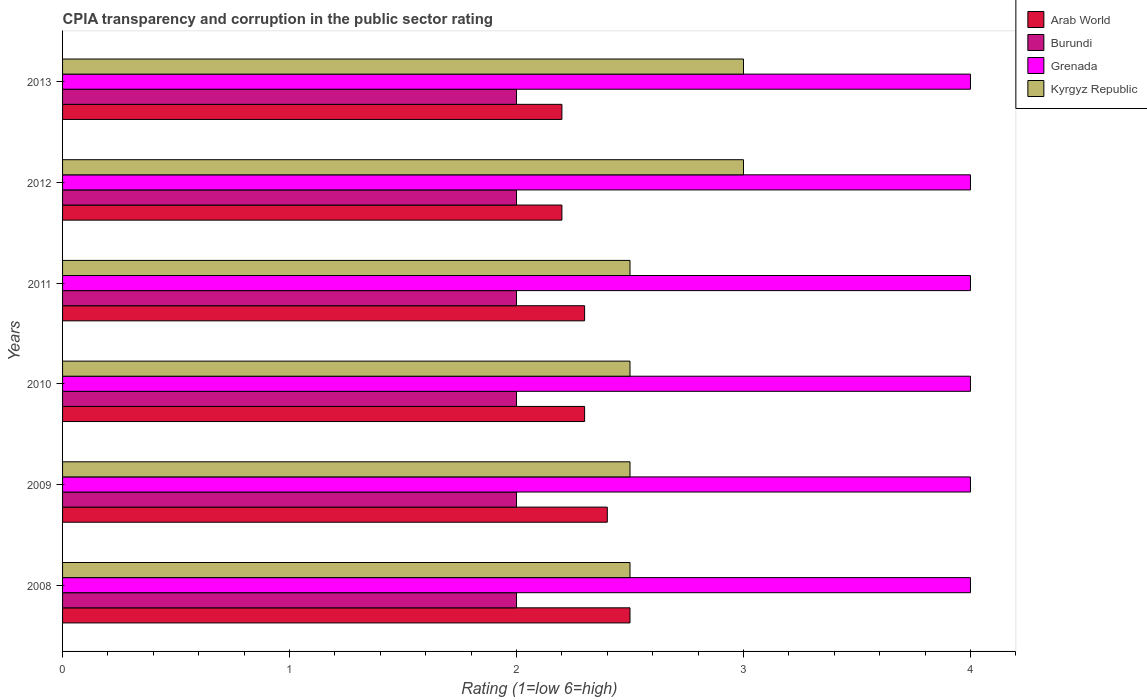In how many cases, is the number of bars for a given year not equal to the number of legend labels?
Your answer should be compact. 0. Across all years, what is the maximum CPIA rating in Grenada?
Your answer should be compact. 4. Across all years, what is the minimum CPIA rating in Grenada?
Your response must be concise. 4. In which year was the CPIA rating in Arab World maximum?
Ensure brevity in your answer.  2008. What is the total CPIA rating in Grenada in the graph?
Offer a terse response. 24. What is the difference between the CPIA rating in Kyrgyz Republic in 2009 and that in 2013?
Give a very brief answer. -0.5. What is the difference between the CPIA rating in Grenada in 2010 and the CPIA rating in Kyrgyz Republic in 2011?
Your answer should be very brief. 1.5. In the year 2013, what is the difference between the CPIA rating in Arab World and CPIA rating in Grenada?
Offer a terse response. -1.8. What is the ratio of the CPIA rating in Kyrgyz Republic in 2009 to that in 2012?
Ensure brevity in your answer.  0.83. Is the CPIA rating in Burundi in 2011 less than that in 2012?
Keep it short and to the point. No. Is the difference between the CPIA rating in Arab World in 2009 and 2013 greater than the difference between the CPIA rating in Grenada in 2009 and 2013?
Your answer should be compact. Yes. In how many years, is the CPIA rating in Kyrgyz Republic greater than the average CPIA rating in Kyrgyz Republic taken over all years?
Keep it short and to the point. 2. Is the sum of the CPIA rating in Burundi in 2012 and 2013 greater than the maximum CPIA rating in Arab World across all years?
Offer a terse response. Yes. What does the 1st bar from the top in 2009 represents?
Provide a succinct answer. Kyrgyz Republic. What does the 3rd bar from the bottom in 2012 represents?
Your response must be concise. Grenada. Are all the bars in the graph horizontal?
Provide a succinct answer. Yes. Where does the legend appear in the graph?
Your response must be concise. Top right. How many legend labels are there?
Give a very brief answer. 4. How are the legend labels stacked?
Keep it short and to the point. Vertical. What is the title of the graph?
Make the answer very short. CPIA transparency and corruption in the public sector rating. Does "Channel Islands" appear as one of the legend labels in the graph?
Make the answer very short. No. What is the Rating (1=low 6=high) in Grenada in 2008?
Keep it short and to the point. 4. What is the Rating (1=low 6=high) of Kyrgyz Republic in 2008?
Give a very brief answer. 2.5. What is the Rating (1=low 6=high) in Arab World in 2009?
Make the answer very short. 2.4. What is the Rating (1=low 6=high) of Kyrgyz Republic in 2009?
Offer a very short reply. 2.5. What is the Rating (1=low 6=high) in Arab World in 2010?
Provide a succinct answer. 2.3. What is the Rating (1=low 6=high) in Kyrgyz Republic in 2010?
Keep it short and to the point. 2.5. What is the Rating (1=low 6=high) in Burundi in 2011?
Provide a succinct answer. 2. What is the Rating (1=low 6=high) of Arab World in 2012?
Give a very brief answer. 2.2. What is the Rating (1=low 6=high) of Burundi in 2012?
Ensure brevity in your answer.  2. What is the Rating (1=low 6=high) in Grenada in 2012?
Your response must be concise. 4. What is the Rating (1=low 6=high) of Grenada in 2013?
Your response must be concise. 4. What is the Rating (1=low 6=high) of Kyrgyz Republic in 2013?
Your answer should be compact. 3. Across all years, what is the maximum Rating (1=low 6=high) of Arab World?
Give a very brief answer. 2.5. Across all years, what is the maximum Rating (1=low 6=high) of Burundi?
Make the answer very short. 2. Across all years, what is the maximum Rating (1=low 6=high) in Grenada?
Your response must be concise. 4. Across all years, what is the maximum Rating (1=low 6=high) of Kyrgyz Republic?
Give a very brief answer. 3. Across all years, what is the minimum Rating (1=low 6=high) of Arab World?
Make the answer very short. 2.2. Across all years, what is the minimum Rating (1=low 6=high) of Burundi?
Keep it short and to the point. 2. Across all years, what is the minimum Rating (1=low 6=high) in Kyrgyz Republic?
Your answer should be very brief. 2.5. What is the total Rating (1=low 6=high) in Burundi in the graph?
Make the answer very short. 12. What is the total Rating (1=low 6=high) in Grenada in the graph?
Provide a short and direct response. 24. What is the total Rating (1=low 6=high) of Kyrgyz Republic in the graph?
Keep it short and to the point. 16. What is the difference between the Rating (1=low 6=high) of Kyrgyz Republic in 2008 and that in 2009?
Ensure brevity in your answer.  0. What is the difference between the Rating (1=low 6=high) in Arab World in 2008 and that in 2011?
Provide a succinct answer. 0.2. What is the difference between the Rating (1=low 6=high) of Kyrgyz Republic in 2008 and that in 2012?
Keep it short and to the point. -0.5. What is the difference between the Rating (1=low 6=high) in Arab World in 2008 and that in 2013?
Offer a terse response. 0.3. What is the difference between the Rating (1=low 6=high) of Grenada in 2008 and that in 2013?
Keep it short and to the point. 0. What is the difference between the Rating (1=low 6=high) of Kyrgyz Republic in 2008 and that in 2013?
Provide a succinct answer. -0.5. What is the difference between the Rating (1=low 6=high) in Burundi in 2009 and that in 2010?
Offer a terse response. 0. What is the difference between the Rating (1=low 6=high) of Kyrgyz Republic in 2009 and that in 2010?
Make the answer very short. 0. What is the difference between the Rating (1=low 6=high) in Kyrgyz Republic in 2009 and that in 2011?
Offer a terse response. 0. What is the difference between the Rating (1=low 6=high) in Arab World in 2009 and that in 2012?
Provide a succinct answer. 0.2. What is the difference between the Rating (1=low 6=high) in Kyrgyz Republic in 2009 and that in 2012?
Keep it short and to the point. -0.5. What is the difference between the Rating (1=low 6=high) of Grenada in 2009 and that in 2013?
Make the answer very short. 0. What is the difference between the Rating (1=low 6=high) in Burundi in 2010 and that in 2011?
Offer a terse response. 0. What is the difference between the Rating (1=low 6=high) of Arab World in 2010 and that in 2012?
Provide a succinct answer. 0.1. What is the difference between the Rating (1=low 6=high) of Kyrgyz Republic in 2010 and that in 2012?
Your answer should be very brief. -0.5. What is the difference between the Rating (1=low 6=high) of Burundi in 2010 and that in 2013?
Your answer should be very brief. 0. What is the difference between the Rating (1=low 6=high) in Grenada in 2010 and that in 2013?
Your answer should be compact. 0. What is the difference between the Rating (1=low 6=high) in Kyrgyz Republic in 2010 and that in 2013?
Offer a very short reply. -0.5. What is the difference between the Rating (1=low 6=high) in Arab World in 2011 and that in 2012?
Your answer should be very brief. 0.1. What is the difference between the Rating (1=low 6=high) of Kyrgyz Republic in 2011 and that in 2012?
Offer a very short reply. -0.5. What is the difference between the Rating (1=low 6=high) of Arab World in 2011 and that in 2013?
Make the answer very short. 0.1. What is the difference between the Rating (1=low 6=high) of Grenada in 2011 and that in 2013?
Provide a short and direct response. 0. What is the difference between the Rating (1=low 6=high) in Burundi in 2012 and that in 2013?
Your answer should be very brief. 0. What is the difference between the Rating (1=low 6=high) of Kyrgyz Republic in 2012 and that in 2013?
Ensure brevity in your answer.  0. What is the difference between the Rating (1=low 6=high) in Arab World in 2008 and the Rating (1=low 6=high) in Kyrgyz Republic in 2009?
Your response must be concise. 0. What is the difference between the Rating (1=low 6=high) in Burundi in 2008 and the Rating (1=low 6=high) in Grenada in 2009?
Keep it short and to the point. -2. What is the difference between the Rating (1=low 6=high) in Burundi in 2008 and the Rating (1=low 6=high) in Kyrgyz Republic in 2009?
Keep it short and to the point. -0.5. What is the difference between the Rating (1=low 6=high) of Grenada in 2008 and the Rating (1=low 6=high) of Kyrgyz Republic in 2009?
Your answer should be compact. 1.5. What is the difference between the Rating (1=low 6=high) in Arab World in 2008 and the Rating (1=low 6=high) in Burundi in 2010?
Offer a very short reply. 0.5. What is the difference between the Rating (1=low 6=high) of Arab World in 2008 and the Rating (1=low 6=high) of Kyrgyz Republic in 2010?
Offer a terse response. 0. What is the difference between the Rating (1=low 6=high) in Burundi in 2008 and the Rating (1=low 6=high) in Grenada in 2011?
Provide a succinct answer. -2. What is the difference between the Rating (1=low 6=high) in Arab World in 2008 and the Rating (1=low 6=high) in Burundi in 2012?
Provide a succinct answer. 0.5. What is the difference between the Rating (1=low 6=high) of Burundi in 2008 and the Rating (1=low 6=high) of Grenada in 2012?
Give a very brief answer. -2. What is the difference between the Rating (1=low 6=high) of Burundi in 2008 and the Rating (1=low 6=high) of Kyrgyz Republic in 2012?
Provide a succinct answer. -1. What is the difference between the Rating (1=low 6=high) of Grenada in 2008 and the Rating (1=low 6=high) of Kyrgyz Republic in 2012?
Give a very brief answer. 1. What is the difference between the Rating (1=low 6=high) in Arab World in 2008 and the Rating (1=low 6=high) in Burundi in 2013?
Your response must be concise. 0.5. What is the difference between the Rating (1=low 6=high) in Arab World in 2008 and the Rating (1=low 6=high) in Grenada in 2013?
Provide a succinct answer. -1.5. What is the difference between the Rating (1=low 6=high) in Burundi in 2008 and the Rating (1=low 6=high) in Grenada in 2013?
Provide a succinct answer. -2. What is the difference between the Rating (1=low 6=high) of Burundi in 2008 and the Rating (1=low 6=high) of Kyrgyz Republic in 2013?
Give a very brief answer. -1. What is the difference between the Rating (1=low 6=high) in Grenada in 2008 and the Rating (1=low 6=high) in Kyrgyz Republic in 2013?
Provide a succinct answer. 1. What is the difference between the Rating (1=low 6=high) in Grenada in 2009 and the Rating (1=low 6=high) in Kyrgyz Republic in 2010?
Provide a short and direct response. 1.5. What is the difference between the Rating (1=low 6=high) in Arab World in 2009 and the Rating (1=low 6=high) in Burundi in 2011?
Make the answer very short. 0.4. What is the difference between the Rating (1=low 6=high) of Arab World in 2009 and the Rating (1=low 6=high) of Grenada in 2011?
Ensure brevity in your answer.  -1.6. What is the difference between the Rating (1=low 6=high) of Burundi in 2009 and the Rating (1=low 6=high) of Grenada in 2011?
Your answer should be compact. -2. What is the difference between the Rating (1=low 6=high) of Burundi in 2009 and the Rating (1=low 6=high) of Kyrgyz Republic in 2011?
Offer a terse response. -0.5. What is the difference between the Rating (1=low 6=high) of Arab World in 2009 and the Rating (1=low 6=high) of Burundi in 2012?
Ensure brevity in your answer.  0.4. What is the difference between the Rating (1=low 6=high) of Arab World in 2009 and the Rating (1=low 6=high) of Grenada in 2012?
Your answer should be compact. -1.6. What is the difference between the Rating (1=low 6=high) in Arab World in 2009 and the Rating (1=low 6=high) in Burundi in 2013?
Give a very brief answer. 0.4. What is the difference between the Rating (1=low 6=high) of Arab World in 2009 and the Rating (1=low 6=high) of Grenada in 2013?
Your answer should be very brief. -1.6. What is the difference between the Rating (1=low 6=high) of Arab World in 2009 and the Rating (1=low 6=high) of Kyrgyz Republic in 2013?
Your answer should be very brief. -0.6. What is the difference between the Rating (1=low 6=high) in Burundi in 2009 and the Rating (1=low 6=high) in Grenada in 2013?
Your answer should be very brief. -2. What is the difference between the Rating (1=low 6=high) in Arab World in 2010 and the Rating (1=low 6=high) in Burundi in 2011?
Give a very brief answer. 0.3. What is the difference between the Rating (1=low 6=high) in Arab World in 2010 and the Rating (1=low 6=high) in Grenada in 2011?
Your answer should be compact. -1.7. What is the difference between the Rating (1=low 6=high) in Arab World in 2010 and the Rating (1=low 6=high) in Kyrgyz Republic in 2011?
Provide a short and direct response. -0.2. What is the difference between the Rating (1=low 6=high) in Grenada in 2010 and the Rating (1=low 6=high) in Kyrgyz Republic in 2011?
Give a very brief answer. 1.5. What is the difference between the Rating (1=low 6=high) of Burundi in 2010 and the Rating (1=low 6=high) of Grenada in 2012?
Give a very brief answer. -2. What is the difference between the Rating (1=low 6=high) in Burundi in 2010 and the Rating (1=low 6=high) in Kyrgyz Republic in 2012?
Your answer should be compact. -1. What is the difference between the Rating (1=low 6=high) of Grenada in 2010 and the Rating (1=low 6=high) of Kyrgyz Republic in 2012?
Give a very brief answer. 1. What is the difference between the Rating (1=low 6=high) in Arab World in 2010 and the Rating (1=low 6=high) in Burundi in 2013?
Make the answer very short. 0.3. What is the difference between the Rating (1=low 6=high) in Arab World in 2010 and the Rating (1=low 6=high) in Grenada in 2013?
Provide a short and direct response. -1.7. What is the difference between the Rating (1=low 6=high) in Arab World in 2010 and the Rating (1=low 6=high) in Kyrgyz Republic in 2013?
Give a very brief answer. -0.7. What is the difference between the Rating (1=low 6=high) in Burundi in 2010 and the Rating (1=low 6=high) in Grenada in 2013?
Keep it short and to the point. -2. What is the difference between the Rating (1=low 6=high) of Burundi in 2010 and the Rating (1=low 6=high) of Kyrgyz Republic in 2013?
Provide a succinct answer. -1. What is the difference between the Rating (1=low 6=high) of Grenada in 2010 and the Rating (1=low 6=high) of Kyrgyz Republic in 2013?
Provide a succinct answer. 1. What is the difference between the Rating (1=low 6=high) of Arab World in 2011 and the Rating (1=low 6=high) of Grenada in 2012?
Give a very brief answer. -1.7. What is the difference between the Rating (1=low 6=high) of Burundi in 2011 and the Rating (1=low 6=high) of Kyrgyz Republic in 2012?
Give a very brief answer. -1. What is the difference between the Rating (1=low 6=high) of Grenada in 2011 and the Rating (1=low 6=high) of Kyrgyz Republic in 2012?
Keep it short and to the point. 1. What is the difference between the Rating (1=low 6=high) in Burundi in 2011 and the Rating (1=low 6=high) in Grenada in 2013?
Offer a terse response. -2. What is the difference between the Rating (1=low 6=high) in Burundi in 2011 and the Rating (1=low 6=high) in Kyrgyz Republic in 2013?
Your response must be concise. -1. What is the difference between the Rating (1=low 6=high) of Arab World in 2012 and the Rating (1=low 6=high) of Burundi in 2013?
Your response must be concise. 0.2. What is the difference between the Rating (1=low 6=high) in Arab World in 2012 and the Rating (1=low 6=high) in Grenada in 2013?
Your response must be concise. -1.8. What is the difference between the Rating (1=low 6=high) of Grenada in 2012 and the Rating (1=low 6=high) of Kyrgyz Republic in 2013?
Provide a short and direct response. 1. What is the average Rating (1=low 6=high) in Arab World per year?
Provide a succinct answer. 2.32. What is the average Rating (1=low 6=high) of Burundi per year?
Ensure brevity in your answer.  2. What is the average Rating (1=low 6=high) in Kyrgyz Republic per year?
Your answer should be very brief. 2.67. In the year 2008, what is the difference between the Rating (1=low 6=high) in Arab World and Rating (1=low 6=high) in Grenada?
Ensure brevity in your answer.  -1.5. In the year 2008, what is the difference between the Rating (1=low 6=high) of Burundi and Rating (1=low 6=high) of Kyrgyz Republic?
Provide a succinct answer. -0.5. In the year 2009, what is the difference between the Rating (1=low 6=high) of Arab World and Rating (1=low 6=high) of Burundi?
Give a very brief answer. 0.4. In the year 2009, what is the difference between the Rating (1=low 6=high) in Arab World and Rating (1=low 6=high) in Grenada?
Your answer should be very brief. -1.6. In the year 2009, what is the difference between the Rating (1=low 6=high) of Arab World and Rating (1=low 6=high) of Kyrgyz Republic?
Your answer should be compact. -0.1. In the year 2009, what is the difference between the Rating (1=low 6=high) of Grenada and Rating (1=low 6=high) of Kyrgyz Republic?
Provide a short and direct response. 1.5. In the year 2010, what is the difference between the Rating (1=low 6=high) of Arab World and Rating (1=low 6=high) of Burundi?
Ensure brevity in your answer.  0.3. In the year 2010, what is the difference between the Rating (1=low 6=high) in Arab World and Rating (1=low 6=high) in Grenada?
Provide a succinct answer. -1.7. In the year 2011, what is the difference between the Rating (1=low 6=high) in Arab World and Rating (1=low 6=high) in Grenada?
Give a very brief answer. -1.7. In the year 2011, what is the difference between the Rating (1=low 6=high) in Arab World and Rating (1=low 6=high) in Kyrgyz Republic?
Offer a terse response. -0.2. In the year 2011, what is the difference between the Rating (1=low 6=high) of Burundi and Rating (1=low 6=high) of Grenada?
Ensure brevity in your answer.  -2. In the year 2011, what is the difference between the Rating (1=low 6=high) in Burundi and Rating (1=low 6=high) in Kyrgyz Republic?
Provide a succinct answer. -0.5. In the year 2012, what is the difference between the Rating (1=low 6=high) of Arab World and Rating (1=low 6=high) of Kyrgyz Republic?
Your answer should be compact. -0.8. In the year 2012, what is the difference between the Rating (1=low 6=high) in Burundi and Rating (1=low 6=high) in Grenada?
Offer a terse response. -2. In the year 2012, what is the difference between the Rating (1=low 6=high) in Burundi and Rating (1=low 6=high) in Kyrgyz Republic?
Keep it short and to the point. -1. In the year 2013, what is the difference between the Rating (1=low 6=high) of Arab World and Rating (1=low 6=high) of Burundi?
Your answer should be compact. 0.2. In the year 2013, what is the difference between the Rating (1=low 6=high) in Arab World and Rating (1=low 6=high) in Grenada?
Your response must be concise. -1.8. In the year 2013, what is the difference between the Rating (1=low 6=high) in Burundi and Rating (1=low 6=high) in Grenada?
Offer a very short reply. -2. In the year 2013, what is the difference between the Rating (1=low 6=high) in Burundi and Rating (1=low 6=high) in Kyrgyz Republic?
Give a very brief answer. -1. In the year 2013, what is the difference between the Rating (1=low 6=high) of Grenada and Rating (1=low 6=high) of Kyrgyz Republic?
Ensure brevity in your answer.  1. What is the ratio of the Rating (1=low 6=high) in Arab World in 2008 to that in 2009?
Make the answer very short. 1.04. What is the ratio of the Rating (1=low 6=high) of Burundi in 2008 to that in 2009?
Keep it short and to the point. 1. What is the ratio of the Rating (1=low 6=high) in Arab World in 2008 to that in 2010?
Provide a succinct answer. 1.09. What is the ratio of the Rating (1=low 6=high) of Kyrgyz Republic in 2008 to that in 2010?
Your answer should be very brief. 1. What is the ratio of the Rating (1=low 6=high) in Arab World in 2008 to that in 2011?
Your answer should be compact. 1.09. What is the ratio of the Rating (1=low 6=high) in Burundi in 2008 to that in 2011?
Offer a very short reply. 1. What is the ratio of the Rating (1=low 6=high) of Arab World in 2008 to that in 2012?
Ensure brevity in your answer.  1.14. What is the ratio of the Rating (1=low 6=high) in Kyrgyz Republic in 2008 to that in 2012?
Make the answer very short. 0.83. What is the ratio of the Rating (1=low 6=high) of Arab World in 2008 to that in 2013?
Your answer should be very brief. 1.14. What is the ratio of the Rating (1=low 6=high) of Burundi in 2008 to that in 2013?
Provide a succinct answer. 1. What is the ratio of the Rating (1=low 6=high) in Grenada in 2008 to that in 2013?
Ensure brevity in your answer.  1. What is the ratio of the Rating (1=low 6=high) of Kyrgyz Republic in 2008 to that in 2013?
Give a very brief answer. 0.83. What is the ratio of the Rating (1=low 6=high) of Arab World in 2009 to that in 2010?
Provide a short and direct response. 1.04. What is the ratio of the Rating (1=low 6=high) in Burundi in 2009 to that in 2010?
Offer a terse response. 1. What is the ratio of the Rating (1=low 6=high) in Arab World in 2009 to that in 2011?
Your answer should be compact. 1.04. What is the ratio of the Rating (1=low 6=high) in Burundi in 2009 to that in 2011?
Offer a very short reply. 1. What is the ratio of the Rating (1=low 6=high) in Grenada in 2009 to that in 2011?
Offer a very short reply. 1. What is the ratio of the Rating (1=low 6=high) of Kyrgyz Republic in 2009 to that in 2012?
Ensure brevity in your answer.  0.83. What is the ratio of the Rating (1=low 6=high) of Arab World in 2009 to that in 2013?
Ensure brevity in your answer.  1.09. What is the ratio of the Rating (1=low 6=high) of Grenada in 2009 to that in 2013?
Ensure brevity in your answer.  1. What is the ratio of the Rating (1=low 6=high) of Kyrgyz Republic in 2009 to that in 2013?
Make the answer very short. 0.83. What is the ratio of the Rating (1=low 6=high) in Kyrgyz Republic in 2010 to that in 2011?
Your answer should be compact. 1. What is the ratio of the Rating (1=low 6=high) in Arab World in 2010 to that in 2012?
Your answer should be very brief. 1.05. What is the ratio of the Rating (1=low 6=high) of Burundi in 2010 to that in 2012?
Offer a very short reply. 1. What is the ratio of the Rating (1=low 6=high) in Kyrgyz Republic in 2010 to that in 2012?
Give a very brief answer. 0.83. What is the ratio of the Rating (1=low 6=high) in Arab World in 2010 to that in 2013?
Provide a short and direct response. 1.05. What is the ratio of the Rating (1=low 6=high) in Grenada in 2010 to that in 2013?
Make the answer very short. 1. What is the ratio of the Rating (1=low 6=high) of Arab World in 2011 to that in 2012?
Offer a very short reply. 1.05. What is the ratio of the Rating (1=low 6=high) in Arab World in 2011 to that in 2013?
Provide a short and direct response. 1.05. What is the ratio of the Rating (1=low 6=high) of Arab World in 2012 to that in 2013?
Your answer should be compact. 1. What is the ratio of the Rating (1=low 6=high) in Burundi in 2012 to that in 2013?
Provide a succinct answer. 1. What is the ratio of the Rating (1=low 6=high) in Grenada in 2012 to that in 2013?
Offer a very short reply. 1. What is the difference between the highest and the second highest Rating (1=low 6=high) in Grenada?
Provide a short and direct response. 0. What is the difference between the highest and the lowest Rating (1=low 6=high) of Arab World?
Your response must be concise. 0.3. What is the difference between the highest and the lowest Rating (1=low 6=high) in Burundi?
Ensure brevity in your answer.  0. What is the difference between the highest and the lowest Rating (1=low 6=high) in Kyrgyz Republic?
Provide a short and direct response. 0.5. 